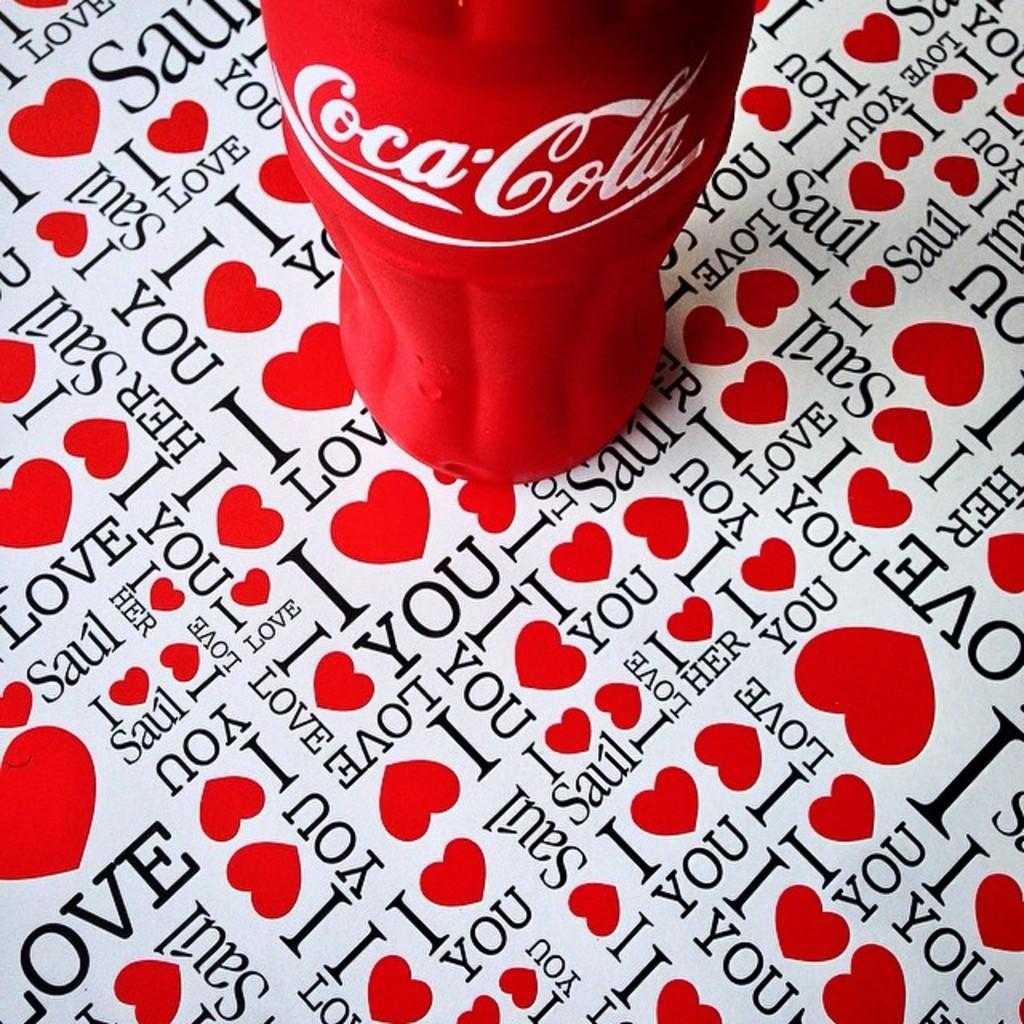Please provide a concise description of this image. In this picture we can see a close view of the red coca cola bottle placed on the table top. 